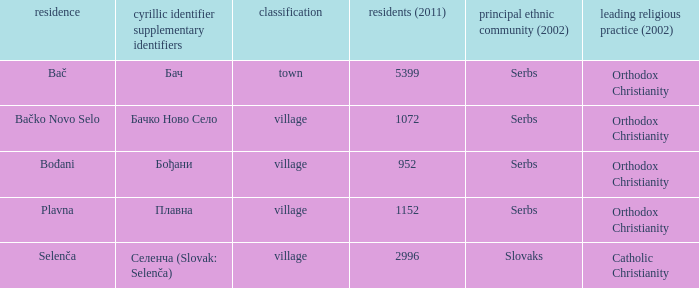What is the second way of writting плавна. Plavna. 